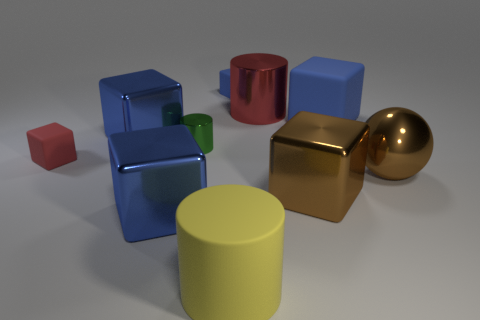Is the number of small rubber blocks that are to the right of the large red metal cylinder the same as the number of small red things that are behind the big yellow matte cylinder?
Your answer should be very brief. No. How many cylinders are either tiny metal objects or blue matte things?
Give a very brief answer. 1. How many other objects are the same material as the big brown block?
Give a very brief answer. 5. What shape is the yellow object in front of the metallic sphere?
Provide a short and direct response. Cylinder. What material is the small block that is on the left side of the big cylinder that is in front of the big red thing?
Ensure brevity in your answer.  Rubber. Is the number of large matte objects right of the tiny blue matte object greater than the number of small matte spheres?
Your answer should be compact. Yes. How many other things are there of the same color as the large ball?
Offer a terse response. 1. What shape is the brown thing that is the same size as the sphere?
Your response must be concise. Cube. What number of green shiny objects are right of the big brown metallic object in front of the brown object that is to the right of the large brown block?
Provide a short and direct response. 0. What number of rubber things are either big balls or yellow things?
Provide a succinct answer. 1. 